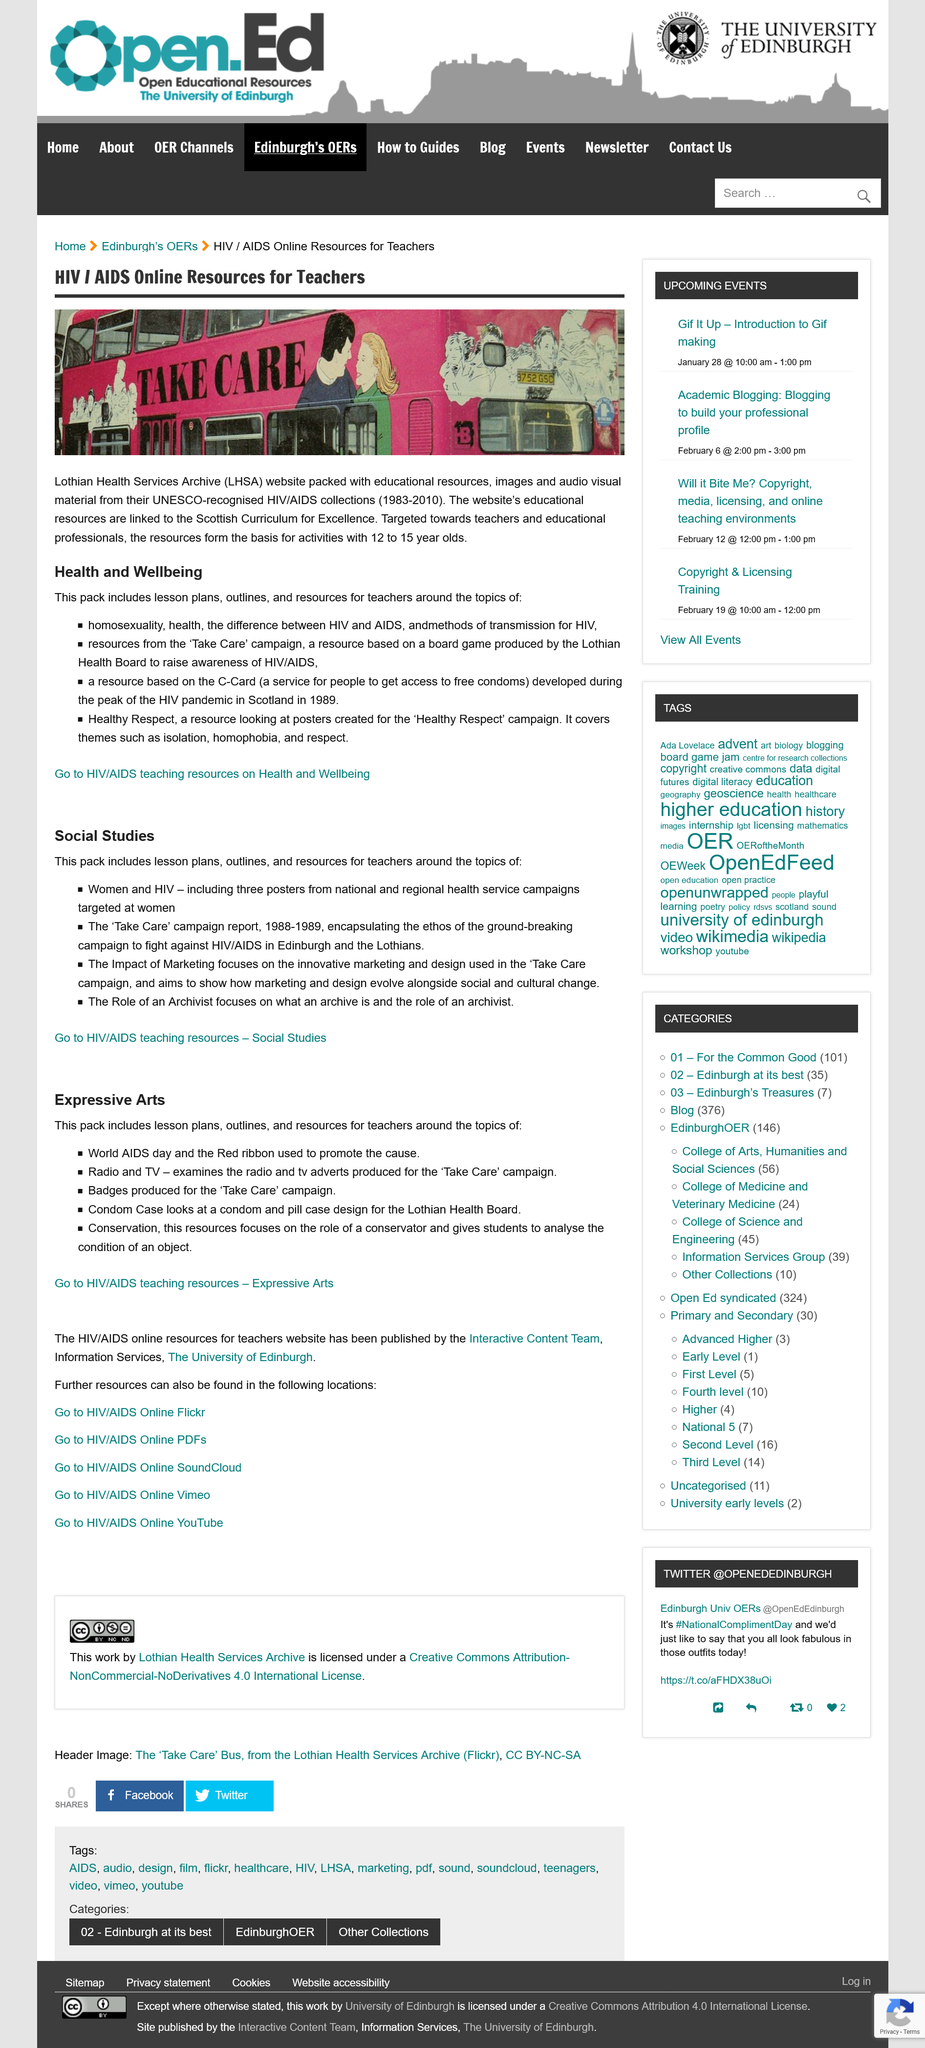Specify some key components in this picture. Yes, the Health and Wellbeing pack includes resources from the 'Take Care' campaign. Yes, the Expressive Arts pack includes lesson plans. The abbreviation LHSA stands for Lothian Health Services Archive. The activities are designed for 12 to 15-year-olds within the age range of 12 to 15 years old. The "Condom Case" examines a proposed design for a condom and pill case intended for use by the Lothian Health Board. 